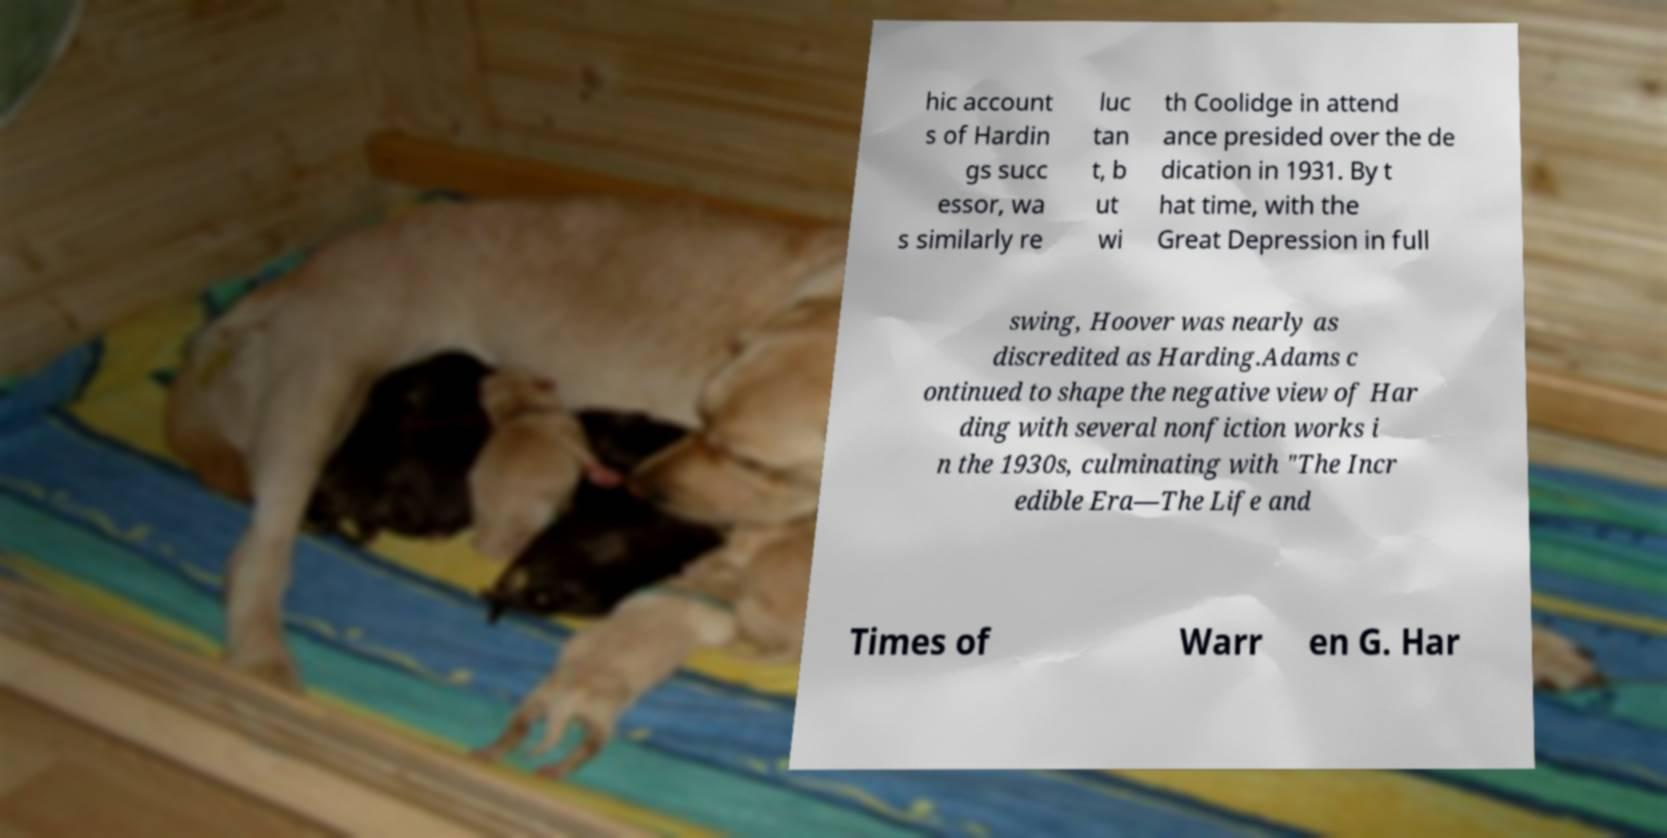For documentation purposes, I need the text within this image transcribed. Could you provide that? hic account s of Hardin gs succ essor, wa s similarly re luc tan t, b ut wi th Coolidge in attend ance presided over the de dication in 1931. By t hat time, with the Great Depression in full swing, Hoover was nearly as discredited as Harding.Adams c ontinued to shape the negative view of Har ding with several nonfiction works i n the 1930s, culminating with "The Incr edible Era—The Life and Times of Warr en G. Har 